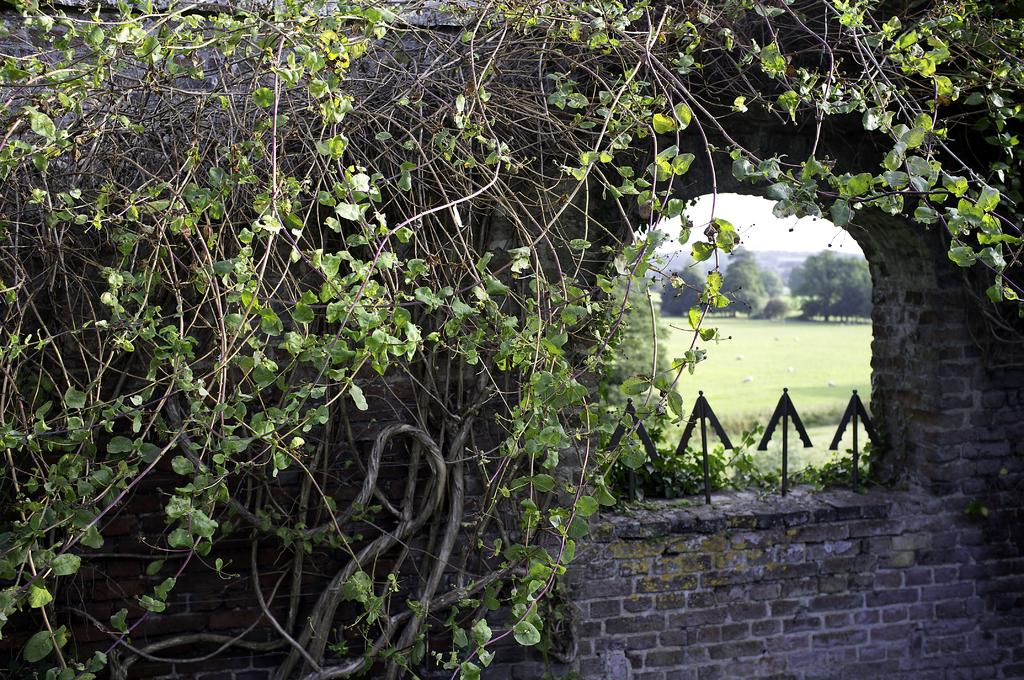What is on the wall in the image? There are plants on the wall in the image. What is located behind the wall in the image? There are trees behind the wall in the image. What type of ground is visible in the image? There is a lawn visible in the image. What is visible above the wall in the image? The sky is visible in the image. What type of flesh can be seen on the plants in the image? There is no flesh visible on the plants in the image; they are made of inanimate materials. What type of ink is used to draw the trees in the image? The image is a photograph, not a drawing, so there is no ink used to depict the trees. 